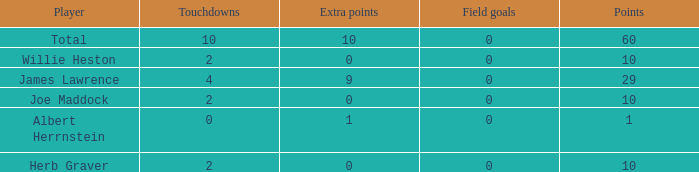What is the highest number of points for players with less than 2 touchdowns and 0 extra points? None. 